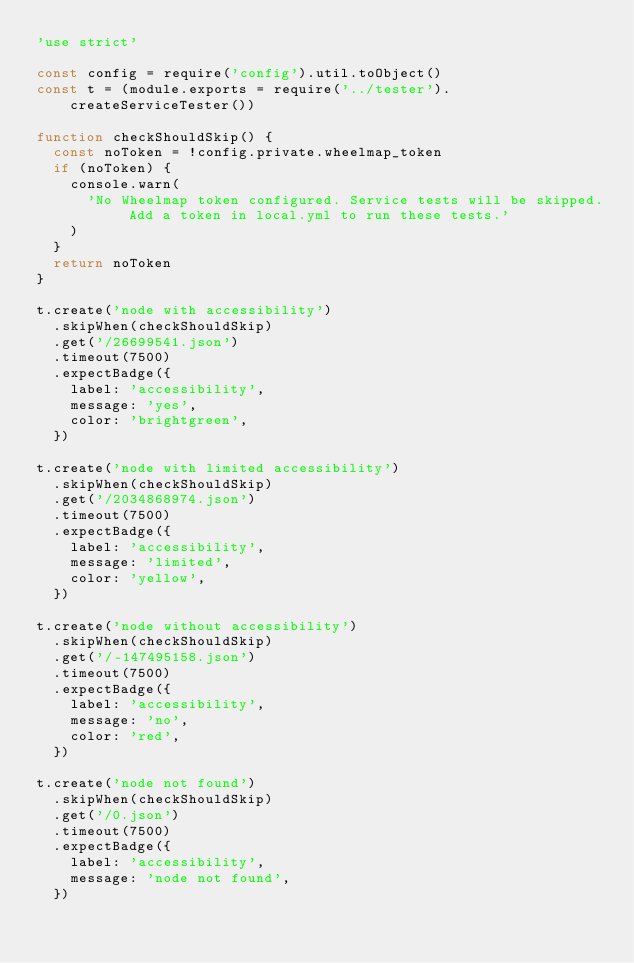<code> <loc_0><loc_0><loc_500><loc_500><_JavaScript_>'use strict'

const config = require('config').util.toObject()
const t = (module.exports = require('../tester').createServiceTester())

function checkShouldSkip() {
  const noToken = !config.private.wheelmap_token
  if (noToken) {
    console.warn(
      'No Wheelmap token configured. Service tests will be skipped. Add a token in local.yml to run these tests.'
    )
  }
  return noToken
}

t.create('node with accessibility')
  .skipWhen(checkShouldSkip)
  .get('/26699541.json')
  .timeout(7500)
  .expectBadge({
    label: 'accessibility',
    message: 'yes',
    color: 'brightgreen',
  })

t.create('node with limited accessibility')
  .skipWhen(checkShouldSkip)
  .get('/2034868974.json')
  .timeout(7500)
  .expectBadge({
    label: 'accessibility',
    message: 'limited',
    color: 'yellow',
  })

t.create('node without accessibility')
  .skipWhen(checkShouldSkip)
  .get('/-147495158.json')
  .timeout(7500)
  .expectBadge({
    label: 'accessibility',
    message: 'no',
    color: 'red',
  })

t.create('node not found')
  .skipWhen(checkShouldSkip)
  .get('/0.json')
  .timeout(7500)
  .expectBadge({
    label: 'accessibility',
    message: 'node not found',
  })
</code> 